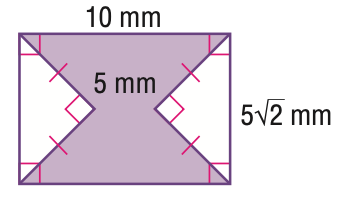Question: Find the area of the shaded region. Round to the nearest tenth if necessary.
Choices:
A. 20.7
B. 45.7
C. 50
D. 70.7
Answer with the letter. Answer: B 